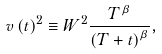<formula> <loc_0><loc_0><loc_500><loc_500>v \left ( t \right ) ^ { 2 } \equiv W ^ { 2 } \frac { T ^ { \beta } } { \left ( T + t \right ) ^ { \beta } } ,</formula> 